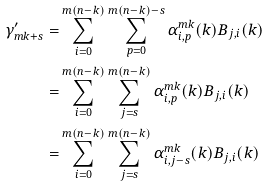<formula> <loc_0><loc_0><loc_500><loc_500>\gamma ^ { \prime } _ { m k + s } = & \sum _ { i = 0 } ^ { m ( n - k ) } \sum _ { p = 0 } ^ { m ( n - k ) - s } \alpha ^ { m k } _ { i , p } ( k ) B _ { j , i } ( k ) \\ = & \sum _ { i = 0 } ^ { m ( n - k ) } \sum _ { j = s } ^ { m ( n - k ) } \alpha ^ { m k } _ { i , p } ( k ) B _ { j , i } ( k ) \\ = & \sum _ { i = 0 } ^ { m ( n - k ) } \sum _ { j = s } ^ { m ( n - k ) } \alpha ^ { m k } _ { i , j - s } ( k ) B _ { j , i } ( k )</formula> 